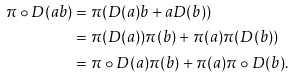Convert formula to latex. <formula><loc_0><loc_0><loc_500><loc_500>\pi \circ D ( a b ) & = \pi ( D ( a ) b + a D ( b ) ) \\ & = \pi ( D ( a ) ) \pi ( b ) + \pi ( a ) \pi ( D ( b ) ) \\ & = \pi \circ D ( a ) \pi ( b ) + \pi ( a ) \pi \circ D ( b ) .</formula> 